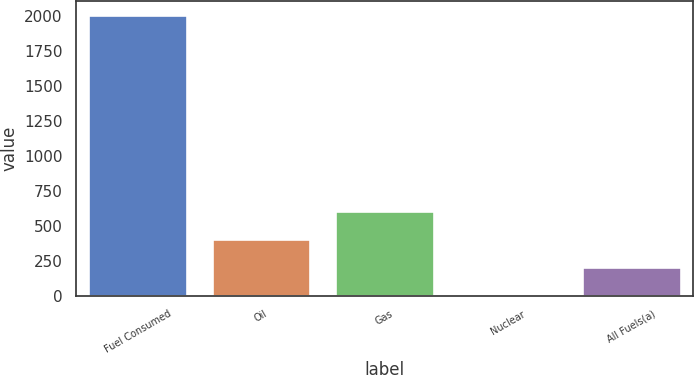Convert chart. <chart><loc_0><loc_0><loc_500><loc_500><bar_chart><fcel>Fuel Consumed<fcel>Oil<fcel>Gas<fcel>Nuclear<fcel>All Fuels(a)<nl><fcel>2007<fcel>401.74<fcel>602.4<fcel>0.42<fcel>201.08<nl></chart> 